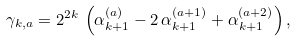<formula> <loc_0><loc_0><loc_500><loc_500>\gamma _ { k , a } = 2 ^ { 2 k } \, \left ( \alpha _ { k + 1 } ^ { ( a ) } - 2 \, \alpha _ { k + 1 } ^ { ( a + 1 ) } + \alpha _ { k + 1 } ^ { ( a + 2 ) } \right ) ,</formula> 